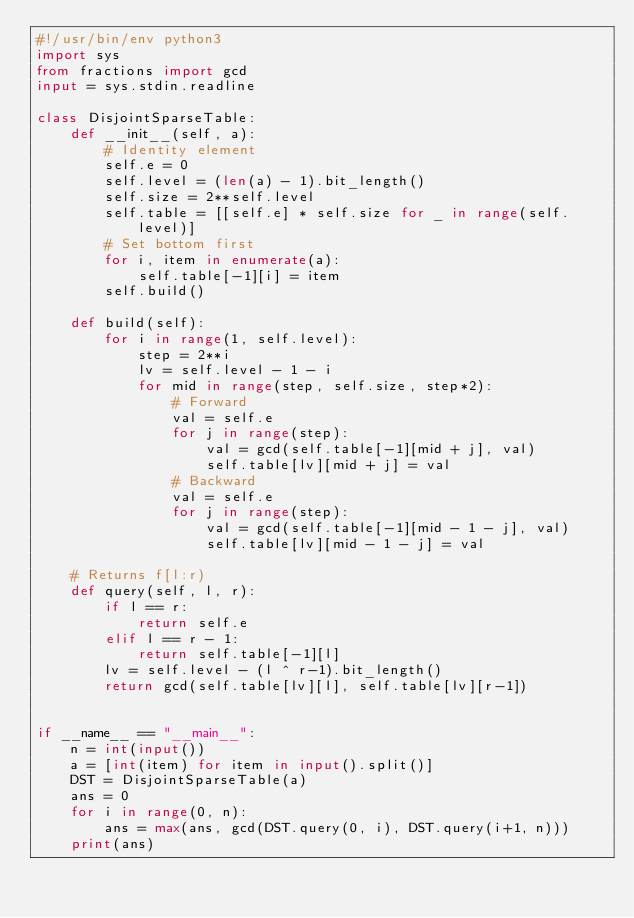<code> <loc_0><loc_0><loc_500><loc_500><_Python_>#!/usr/bin/env python3
import sys
from fractions import gcd
input = sys.stdin.readline

class DisjointSparseTable:
    def __init__(self, a):
        # Identity element
        self.e = 0
        self.level = (len(a) - 1).bit_length()
        self.size = 2**self.level
        self.table = [[self.e] * self.size for _ in range(self.level)]
        # Set bottom first
        for i, item in enumerate(a):
            self.table[-1][i] = item
        self.build()

    def build(self):
        for i in range(1, self.level):
            step = 2**i
            lv = self.level - 1 - i
            for mid in range(step, self.size, step*2):
                # Forward
                val = self.e 
                for j in range(step):
                    val = gcd(self.table[-1][mid + j], val)
                    self.table[lv][mid + j] = val
                # Backward
                val = self.e
                for j in range(step):
                    val = gcd(self.table[-1][mid - 1 - j], val)
                    self.table[lv][mid - 1 - j] = val

    # Returns f[l:r)
    def query(self, l, r):
        if l == r:
            return self.e
        elif l == r - 1:
            return self.table[-1][l]
        lv = self.level - (l ^ r-1).bit_length()
        return gcd(self.table[lv][l], self.table[lv][r-1])

 
if __name__ == "__main__":
    n = int(input())
    a = [int(item) for item in input().split()]
    DST = DisjointSparseTable(a)
    ans = 0
    for i in range(0, n):
        ans = max(ans, gcd(DST.query(0, i), DST.query(i+1, n)))
    print(ans)</code> 